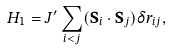Convert formula to latex. <formula><loc_0><loc_0><loc_500><loc_500>H _ { 1 } = J ^ { \prime } \sum _ { i < j } ( \mathbf S _ { i } \cdot \mathbf S _ { j } ) \delta r _ { i j } ,</formula> 